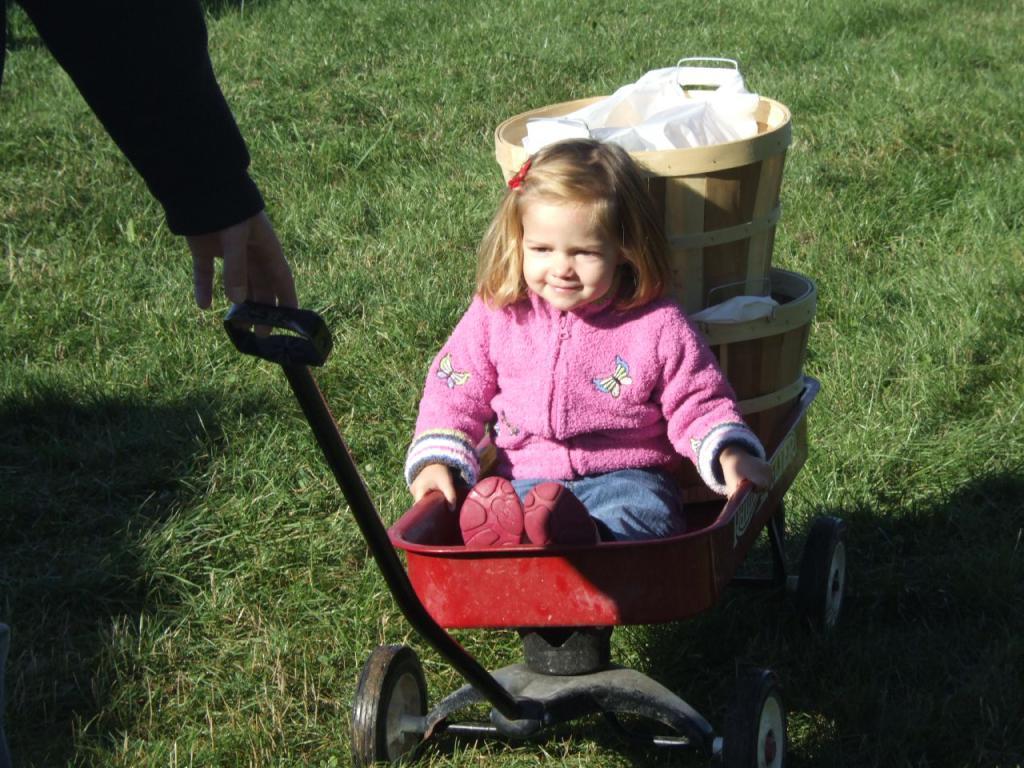Could you give a brief overview of what you see in this image? In the middle of the image there is a stroller. Inside the stroller there is a girl with pink jacket is sitting on it. Behind the girl there are two baskets in the stroller. And the stroller is on the grass. To the stroller there is a rod where a person hand is holding it. 